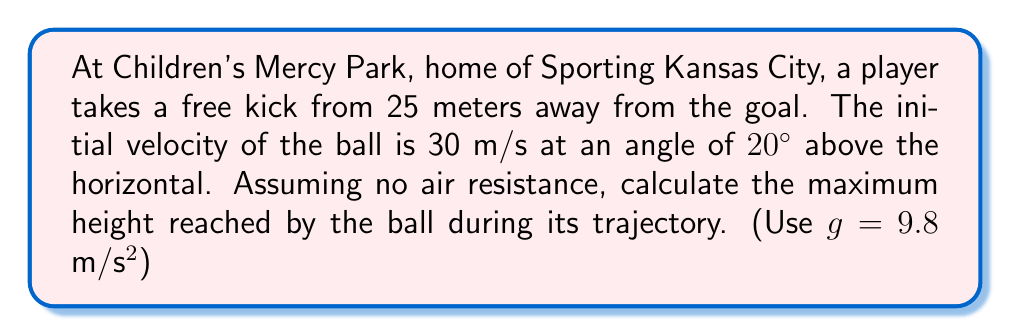Help me with this question. Let's approach this step-by-step using calculus and physics principles:

1) First, we need to break down the initial velocity into its horizontal and vertical components:

   $v_{0x} = v_0 \cos \theta = 30 \cos 20° = 28.19$ m/s
   $v_{0y} = v_0 \sin \theta = 30 \sin 20° = 10.26$ m/s

2) The vertical motion of the ball follows the equation:

   $y(t) = v_{0y}t - \frac{1}{2}gt^2$

   where $y$ is the height, $t$ is time, and $g$ is acceleration due to gravity.

3) To find the maximum height, we need to find when the vertical velocity is zero:

   $\frac{dy}{dt} = v_{0y} - gt = 0$

4) Solving for $t$:

   $t = \frac{v_{0y}}{g} = \frac{10.26}{9.8} = 1.047$ seconds

5) Now we can substitute this time back into our equation for $y(t)$:

   $$\begin{align}
   y_{max} &= v_{0y}t - \frac{1}{2}gt^2 \\
   &= 10.26(1.047) - \frac{1}{2}(9.8)(1.047)^2 \\
   &= 10.74 - 5.37 \\
   &= 5.37 \text{ meters}
   \end{align}$$

Therefore, the maximum height reached by the ball is approximately 5.37 meters.
Answer: 5.37 meters 